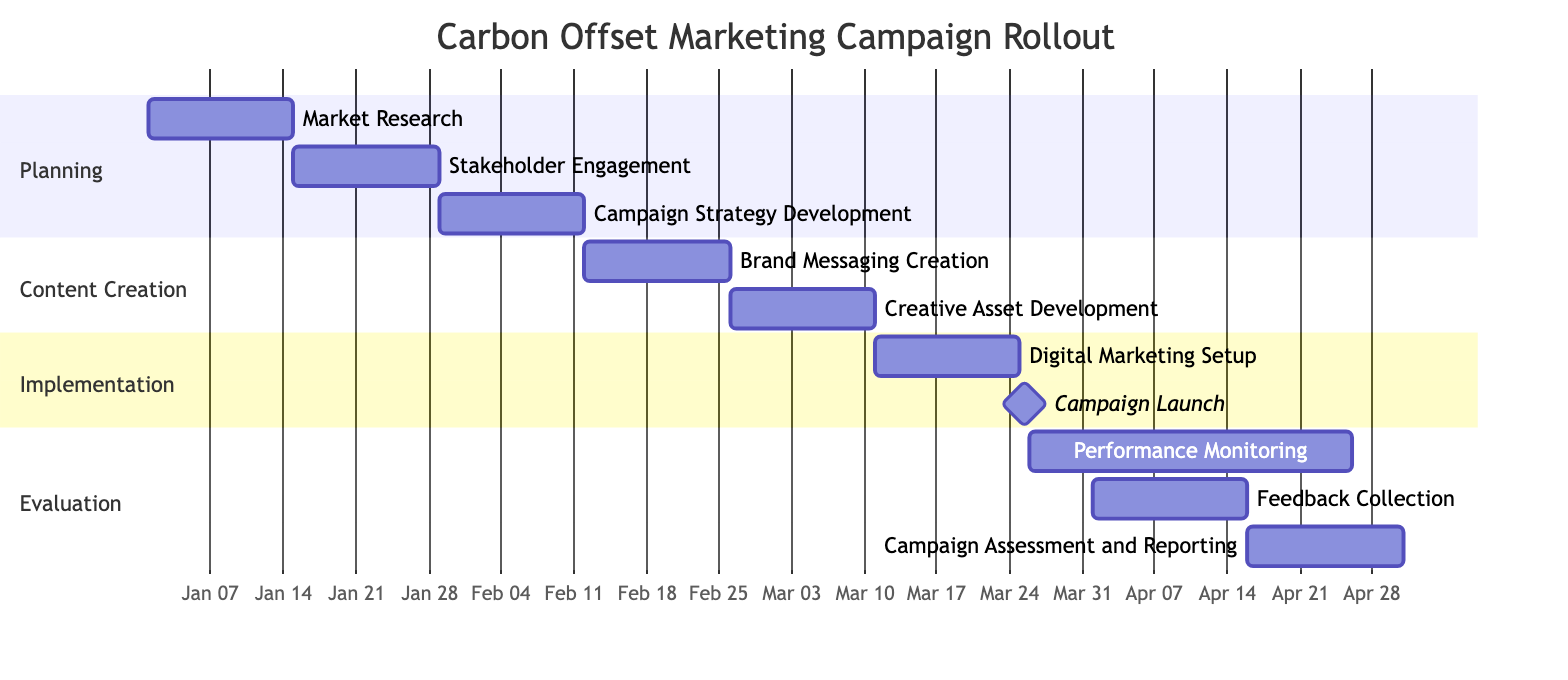What is the duration of the "Market Research" task? The "Market Research" task starts on January 1, 2024, and ends on January 14, 2024. Thus, it lasts for 14 days.
Answer: 14 days Which task follows "Campaign Strategy Development"? In the Gantt chart, the task that follows "Campaign Strategy Development" is "Brand Messaging Creation," which starts immediately after it.
Answer: Brand Messaging Creation What is the total number of tasks in the campaign? Counting all the distinct tasks listed in the Gantt chart, there are 10 tasks in total.
Answer: 10 During which section does "Digital Marketing Setup" occur? "Digital Marketing Setup" is listed under the "Implementation" section of the Gantt chart.
Answer: Implementation What is the start date of the "Feedback Collection" task? The "Feedback Collection" task begins on April 1, 2024, as specified in the Gantt chart.
Answer: April 1, 2024 What is the end date for "Campaign Assessment and Reporting"? The "Campaign Assessment and Reporting" task ends on April 30, 2024, as shown in the Gantt chart.
Answer: April 30, 2024 How many days occur between the "Campaign Launch" and the start of "Performance Monitoring"? The "Campaign Launch" ends on March 30, 2024, and "Performance Monitoring" starts on March 31, 2024, which means there is 1 day between them.
Answer: 1 day Which task has a milestone designation? The "Campaign Launch" task is marked with a milestone designation in the Gantt chart.
Answer: Campaign Launch What is the last task of the marketing campaign? From the Gantt chart timeline, the last task is "Campaign Assessment and Reporting," which finalizes the campaign process.
Answer: Campaign Assessment and Reporting 